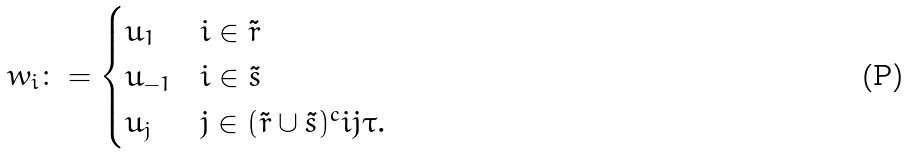Convert formula to latex. <formula><loc_0><loc_0><loc_500><loc_500>w _ { i } \colon = \begin{cases} u _ { 1 } & i \in \tilde { r } \\ u _ { - 1 } & i \in \tilde { s } \\ u _ { j } & j \in ( \tilde { r } \cup \tilde { s } ) ^ { c } i j \tau . \end{cases}</formula> 